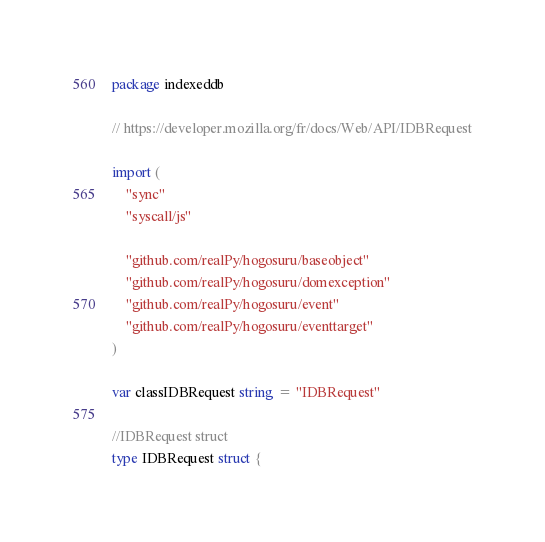Convert code to text. <code><loc_0><loc_0><loc_500><loc_500><_Go_>package indexeddb

// https://developer.mozilla.org/fr/docs/Web/API/IDBRequest

import (
	"sync"
	"syscall/js"

	"github.com/realPy/hogosuru/baseobject"
	"github.com/realPy/hogosuru/domexception"
	"github.com/realPy/hogosuru/event"
	"github.com/realPy/hogosuru/eventtarget"
)

var classIDBRequest string = "IDBRequest"

//IDBRequest struct
type IDBRequest struct {</code> 